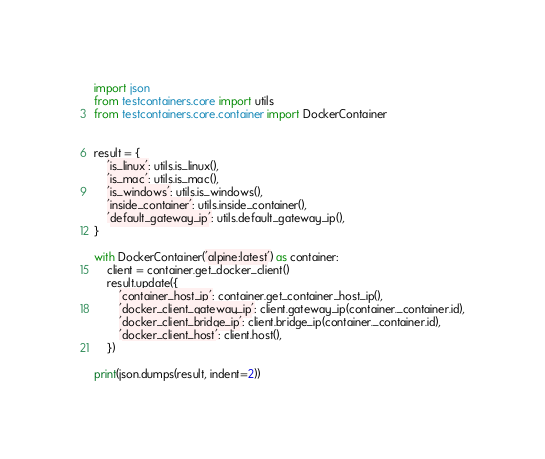<code> <loc_0><loc_0><loc_500><loc_500><_Python_>import json
from testcontainers.core import utils
from testcontainers.core.container import DockerContainer


result = {
    'is_linux': utils.is_linux(),
    'is_mac': utils.is_mac(),
    'is_windows': utils.is_windows(),
    'inside_container': utils.inside_container(),
    'default_gateway_ip': utils.default_gateway_ip(),
}

with DockerContainer('alpine:latest') as container:
    client = container.get_docker_client()
    result.update({
        'container_host_ip': container.get_container_host_ip(),
        'docker_client_gateway_ip': client.gateway_ip(container._container.id),
        'docker_client_bridge_ip': client.bridge_ip(container._container.id),
        'docker_client_host': client.host(),
    })

print(json.dumps(result, indent=2))
</code> 